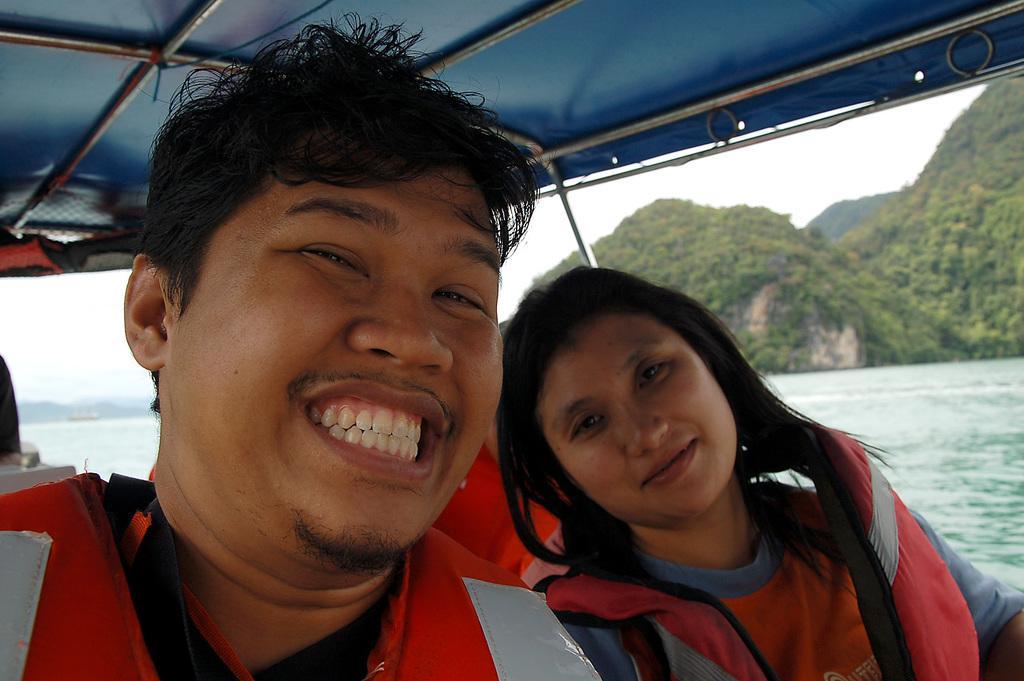Can you describe this image briefly? In this image, I can see the man and woman sitting and smiling. I think these people are sitting in a boat. On the right side of the image, I can see the hills with trees. I can see the water. 